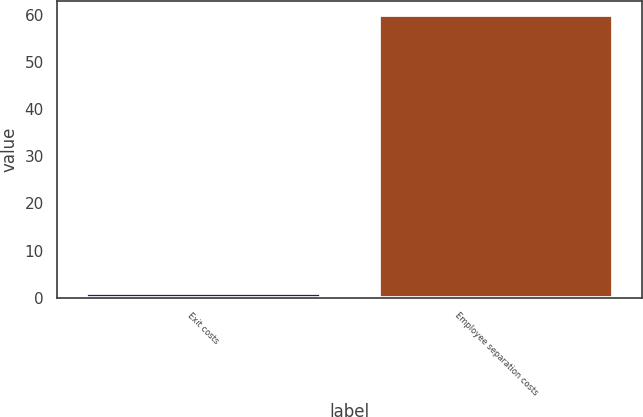Convert chart. <chart><loc_0><loc_0><loc_500><loc_500><bar_chart><fcel>Exit costs<fcel>Employee separation costs<nl><fcel>1<fcel>60<nl></chart> 